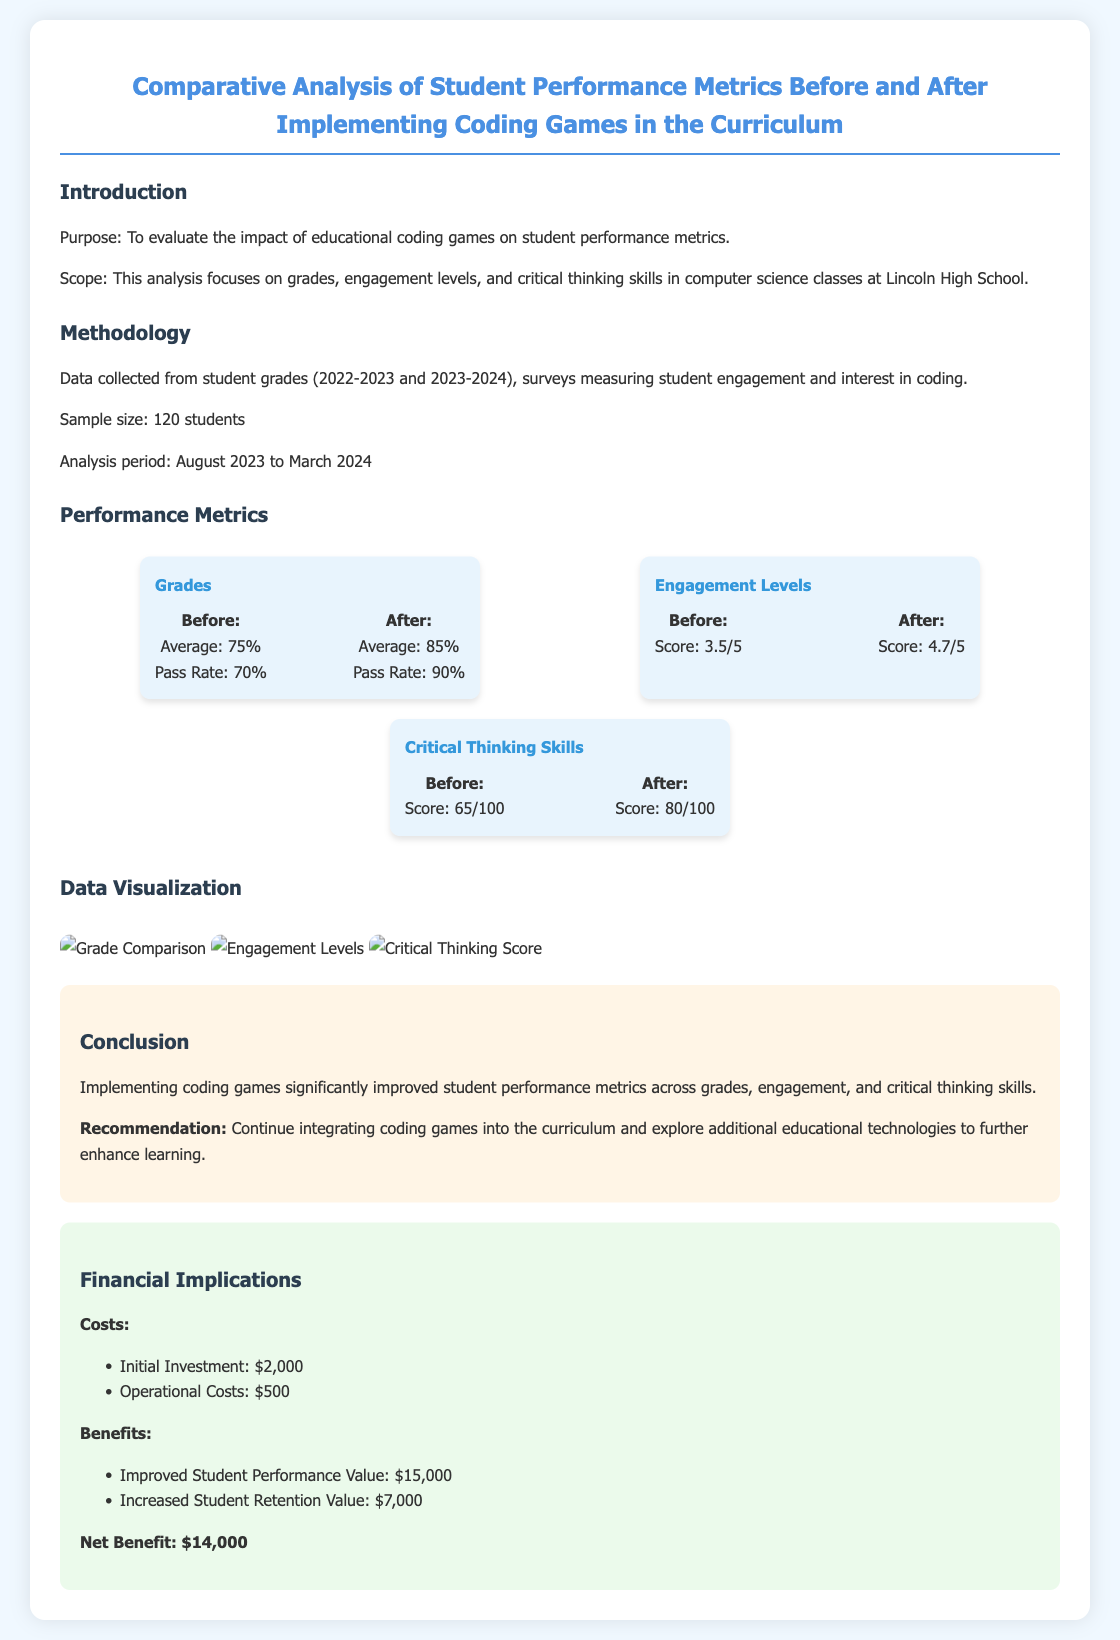What was the average grade before implementing coding games? The average grade before implementing coding games is highlighted in the performance metrics section of the report.
Answer: 75% What was the engagement score after implementing coding games? The engagement score after implementing coding games is found in the performance metrics section of the document.
Answer: 4.7/5 What is the initial investment cost for implementing coding games? The initial investment cost is specified in the financial implications section of the report.
Answer: $2,000 What was the pass rate after implementing coding games? The pass rate after implementing coding games is mentioned in the performance metrics section.
Answer: 90% What was the score for critical thinking skills before the implementation? The score for critical thinking skills before the implementation is stated in the performance metrics section.
Answer: 65/100 Which metric had the largest improvement in percentage terms? This requires comparing the changes in various metrics before and after the implementation, focusing on grade improvement and critical thinking skills.
Answer: Grades What was the total net benefit achieved? The net benefit is detailed in the financial implications section of the report.
Answer: $14,000 What is the purpose of the analysis mentioned in the introduction? The purpose of the analysis is outlined in the introduction section, focusing on evaluating the impact of coding games.
Answer: To evaluate the impact of educational coding games on student performance metrics 